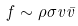<formula> <loc_0><loc_0><loc_500><loc_500>f \sim \rho \sigma v \bar { v }</formula> 